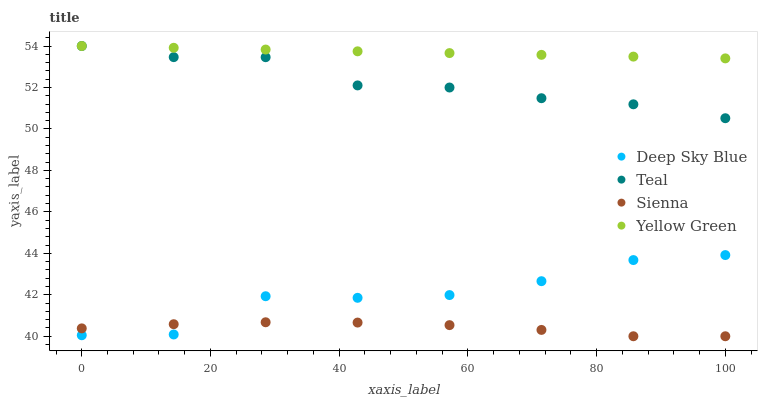Does Sienna have the minimum area under the curve?
Answer yes or no. Yes. Does Yellow Green have the maximum area under the curve?
Answer yes or no. Yes. Does Teal have the minimum area under the curve?
Answer yes or no. No. Does Teal have the maximum area under the curve?
Answer yes or no. No. Is Yellow Green the smoothest?
Answer yes or no. Yes. Is Deep Sky Blue the roughest?
Answer yes or no. Yes. Is Teal the smoothest?
Answer yes or no. No. Is Teal the roughest?
Answer yes or no. No. Does Sienna have the lowest value?
Answer yes or no. Yes. Does Teal have the lowest value?
Answer yes or no. No. Does Yellow Green have the highest value?
Answer yes or no. Yes. Does Deep Sky Blue have the highest value?
Answer yes or no. No. Is Deep Sky Blue less than Teal?
Answer yes or no. Yes. Is Teal greater than Deep Sky Blue?
Answer yes or no. Yes. Does Teal intersect Yellow Green?
Answer yes or no. Yes. Is Teal less than Yellow Green?
Answer yes or no. No. Is Teal greater than Yellow Green?
Answer yes or no. No. Does Deep Sky Blue intersect Teal?
Answer yes or no. No. 